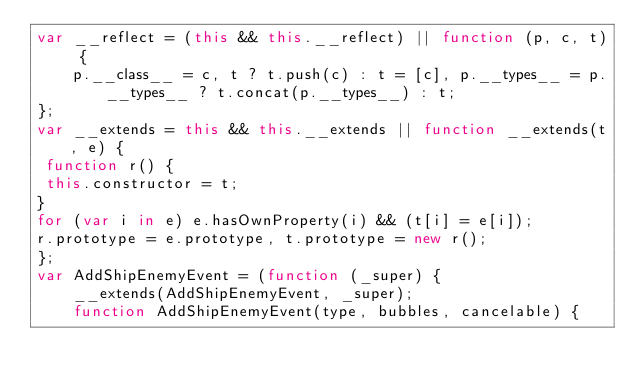Convert code to text. <code><loc_0><loc_0><loc_500><loc_500><_JavaScript_>var __reflect = (this && this.__reflect) || function (p, c, t) {
    p.__class__ = c, t ? t.push(c) : t = [c], p.__types__ = p.__types__ ? t.concat(p.__types__) : t;
};
var __extends = this && this.__extends || function __extends(t, e) { 
 function r() { 
 this.constructor = t;
}
for (var i in e) e.hasOwnProperty(i) && (t[i] = e[i]);
r.prototype = e.prototype, t.prototype = new r();
};
var AddShipEnemyEvent = (function (_super) {
    __extends(AddShipEnemyEvent, _super);
    function AddShipEnemyEvent(type, bubbles, cancelable) {</code> 